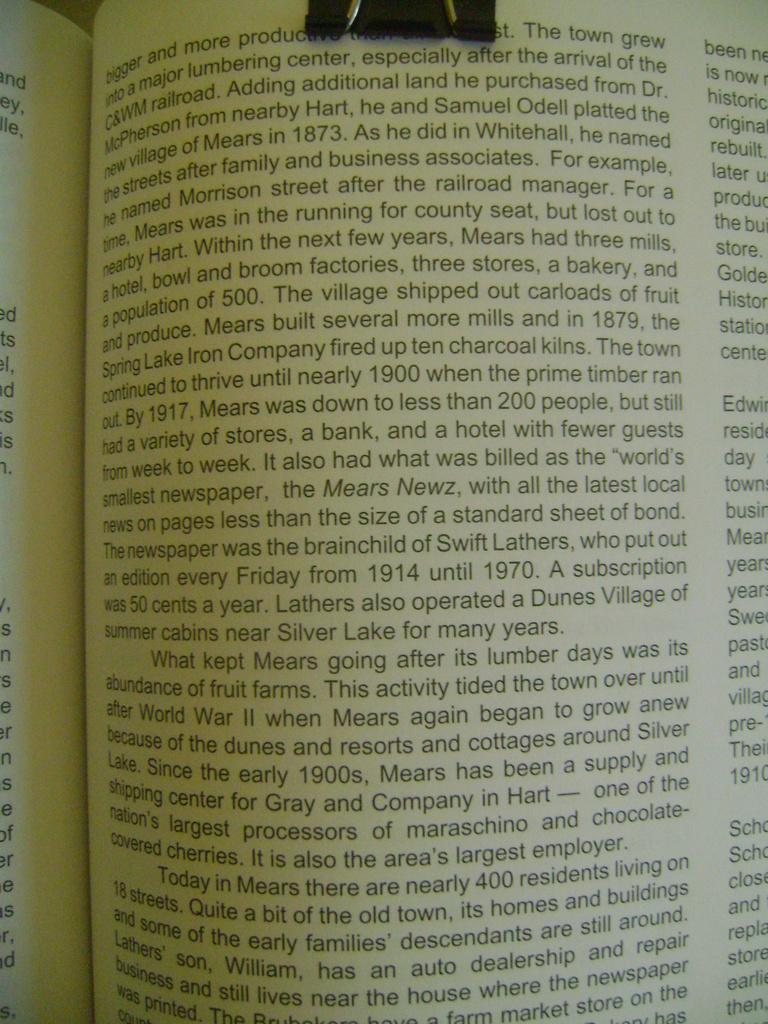<image>
Share a concise interpretation of the image provided. a book opened up to a page that says 'bigger and more' on it 